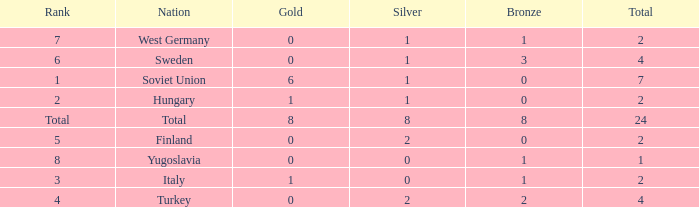For hungary with 1 gold and a negative number of bronze medals, what is the highest total achievable? None. 